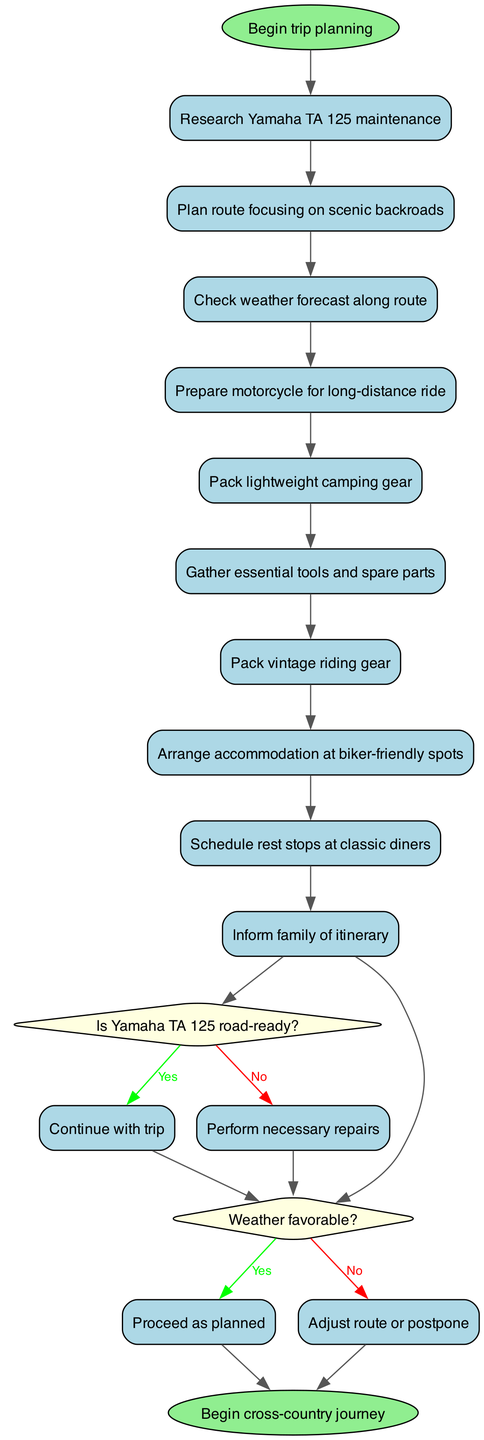What is the starting activity in the trip planning? The diagram begins with the node labeled "Begin trip planning," which indicates the initiation of the trip planning process.
Answer: Begin trip planning How many activities are included in the diagram? By counting the nodes labeled as activities, we find that there are a total of 9 activities listed.
Answer: 9 What question is asked about the Yamaha TA 125? The decision node asks, "Is Yamaha TA 125 road-ready?" which directly refers to the condition of the motorcycle before proceeding further.
Answer: Is Yamaha TA 125 road-ready? What happens if the weather is not favorable? If the "Weather favorable?" decision results in "No," the flow indicates that the next action will be to "Adjust route or postpone," showing the consequence of the unfavorable weather.
Answer: Adjust route or postpone Which activity follows "Pack lightweight camping gear"? The activity that directly follows "Pack lightweight camping gear" is "Gather essential tools and spare parts," indicating the sequence of activities in the planning process.
Answer: Gather essential tools and spare parts What is the end node of the diagram? The diagram concludes with the node labeled "Begin cross-country journey," signifying the final step in the planning and preparation for the trip.
Answer: Begin cross-country journey What color represents decision nodes in the diagram? The decision nodes are represented in light yellow color, distinguishing them from other types of nodes in the diagram.
Answer: Light yellow What happens if Yamaha TA 125 requires repairs? If the decision node "Is Yamaha TA 125 road-ready?" results in "No," the subsequent action outlined is "Perform necessary repairs," which indicates what to do in that case.
Answer: Perform necessary repairs How are rest stops scheduled in the trip planning? Rest stops are scheduled at classic diners, as indicated by the specific activity within the planned activities.
Answer: Schedule rest stops at classic diners 